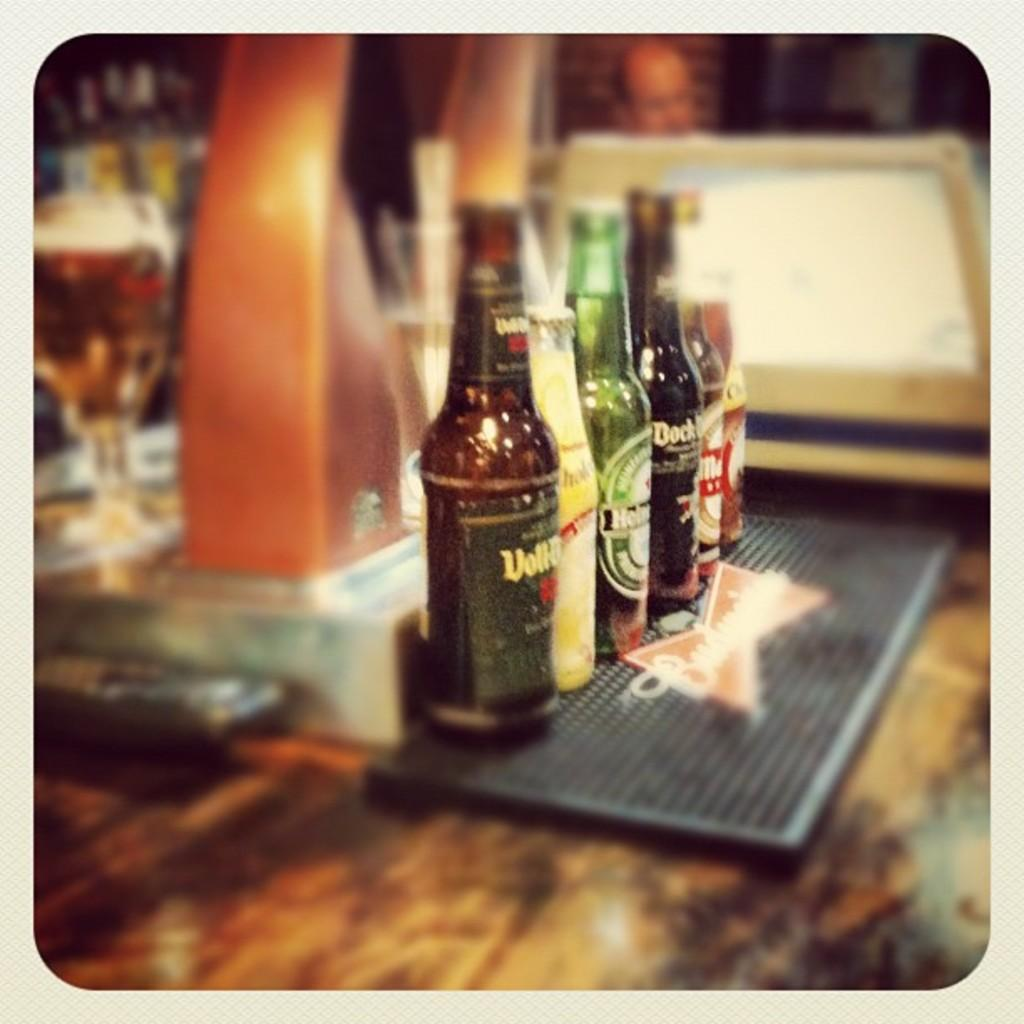What type of beverage containers are in the image? There are beer bottles in the image. Where are the beer bottles located in the image? The beer bottles are in the middle of the image. What sense is being used to taste the beer in the image? The image does not show anyone tasting the beer, so it is not possible to determine which sense is being used. 